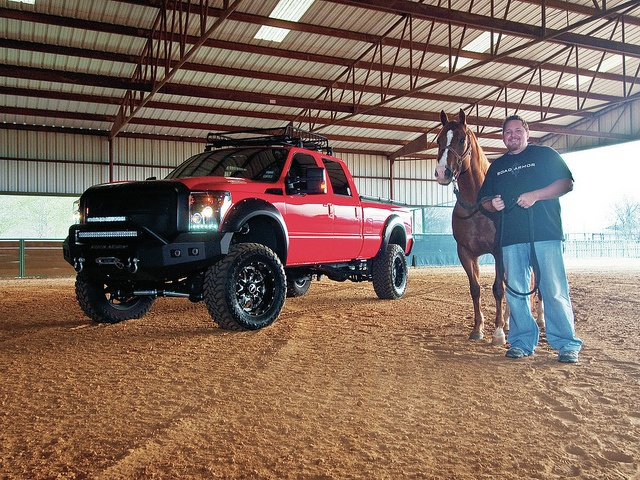Describe the objects in this image and their specific colors. I can see truck in olive, black, brown, white, and gray tones, people in olive, blue, gray, and teal tones, and horse in olive, gray, and black tones in this image. 